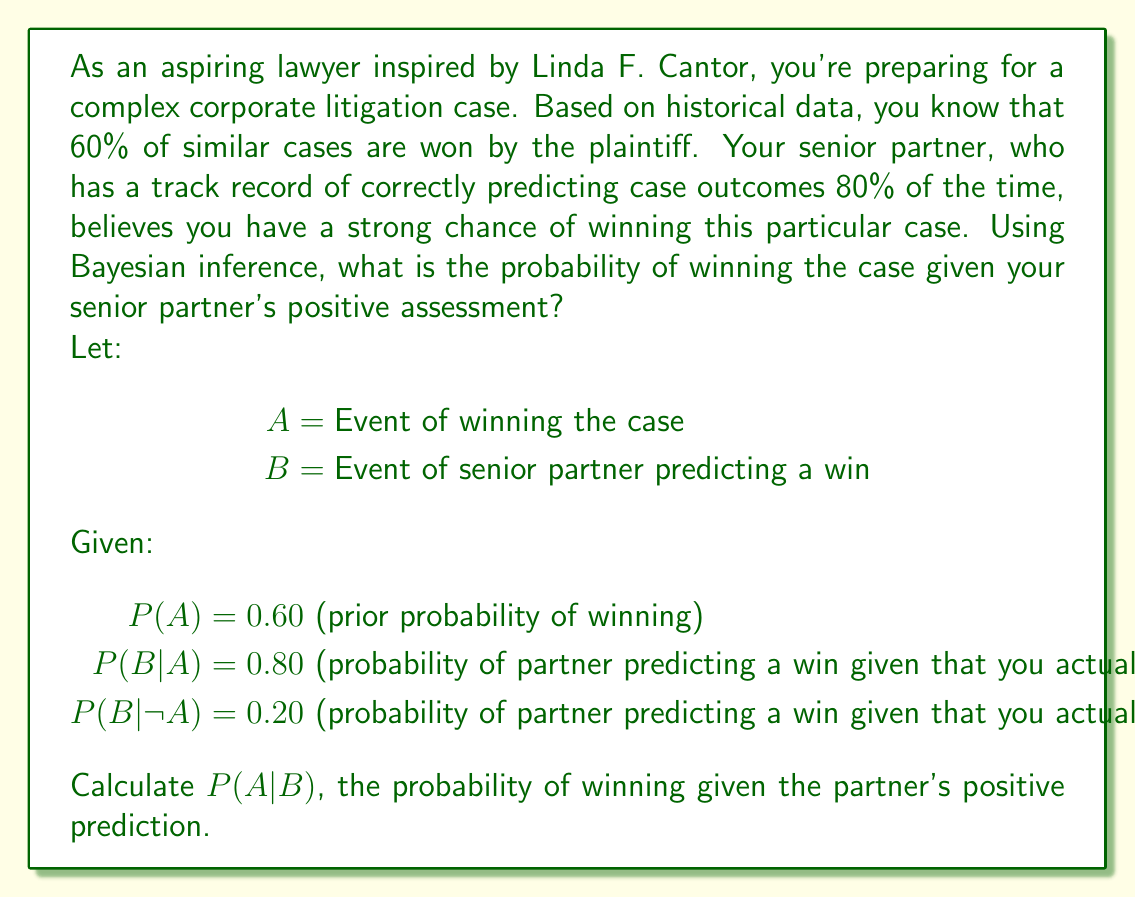Teach me how to tackle this problem. To solve this problem, we'll use Bayes' theorem:

$$P(A|B) = \frac{P(B|A) \cdot P(A)}{P(B)}$$

We're given $P(A)$, $P(B|A)$, and $P(B|\neg A)$. We need to calculate $P(B)$ using the law of total probability:

$$P(B) = P(B|A) \cdot P(A) + P(B|\neg A) \cdot P(\neg A)$$

Step 1: Calculate $P(\neg A)$
$P(\neg A) = 1 - P(A) = 1 - 0.60 = 0.40$

Step 2: Calculate $P(B)$
$$\begin{align*}
P(B) &= P(B|A) \cdot P(A) + P(B|\neg A) \cdot P(\neg A) \\
&= 0.80 \cdot 0.60 + 0.20 \cdot 0.40 \\
&= 0.48 + 0.08 \\
&= 0.56
\end{align*}$$

Step 3: Apply Bayes' theorem
$$\begin{align*}
P(A|B) &= \frac{P(B|A) \cdot P(A)}{P(B)} \\
&= \frac{0.80 \cdot 0.60}{0.56} \\
&= \frac{0.48}{0.56} \\
&\approx 0.8571
\end{align*}$$

Therefore, the probability of winning the case given your senior partner's positive assessment is approximately 0.8571 or 85.71%.
Answer: $P(A|B) \approx 0.8571$ or 85.71% 